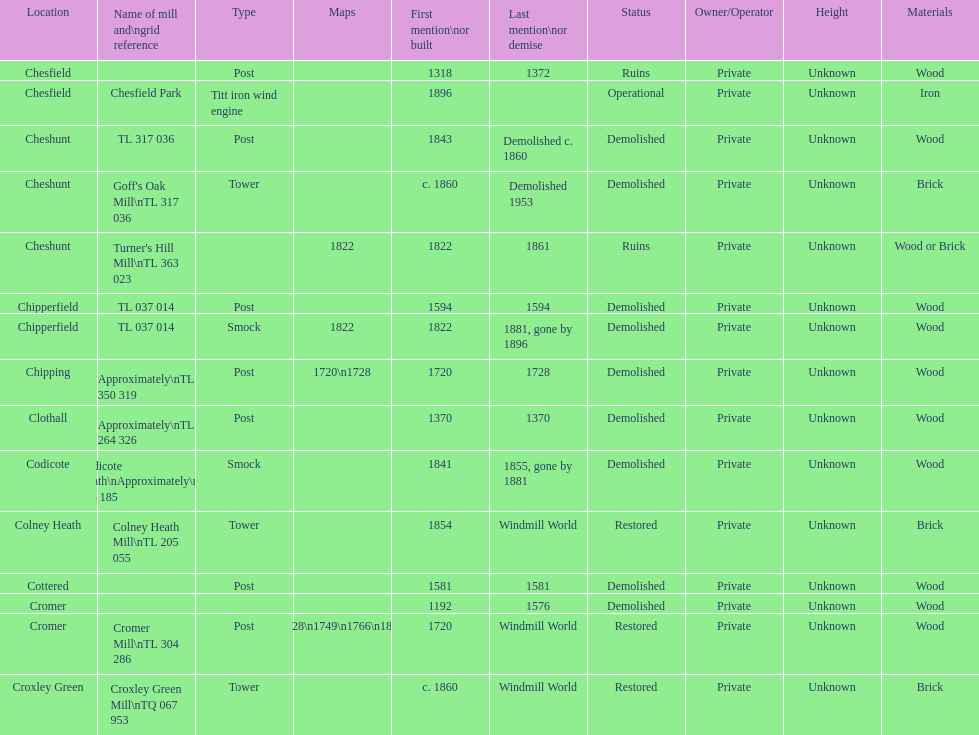How many locations have or had at least 2 windmills? 4. 